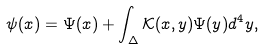Convert formula to latex. <formula><loc_0><loc_0><loc_500><loc_500>\psi ( x ) = \Psi ( x ) + \int _ { \Delta } \mathcal { K } ( x , y ) \Psi ( y ) d ^ { 4 } y ,</formula> 